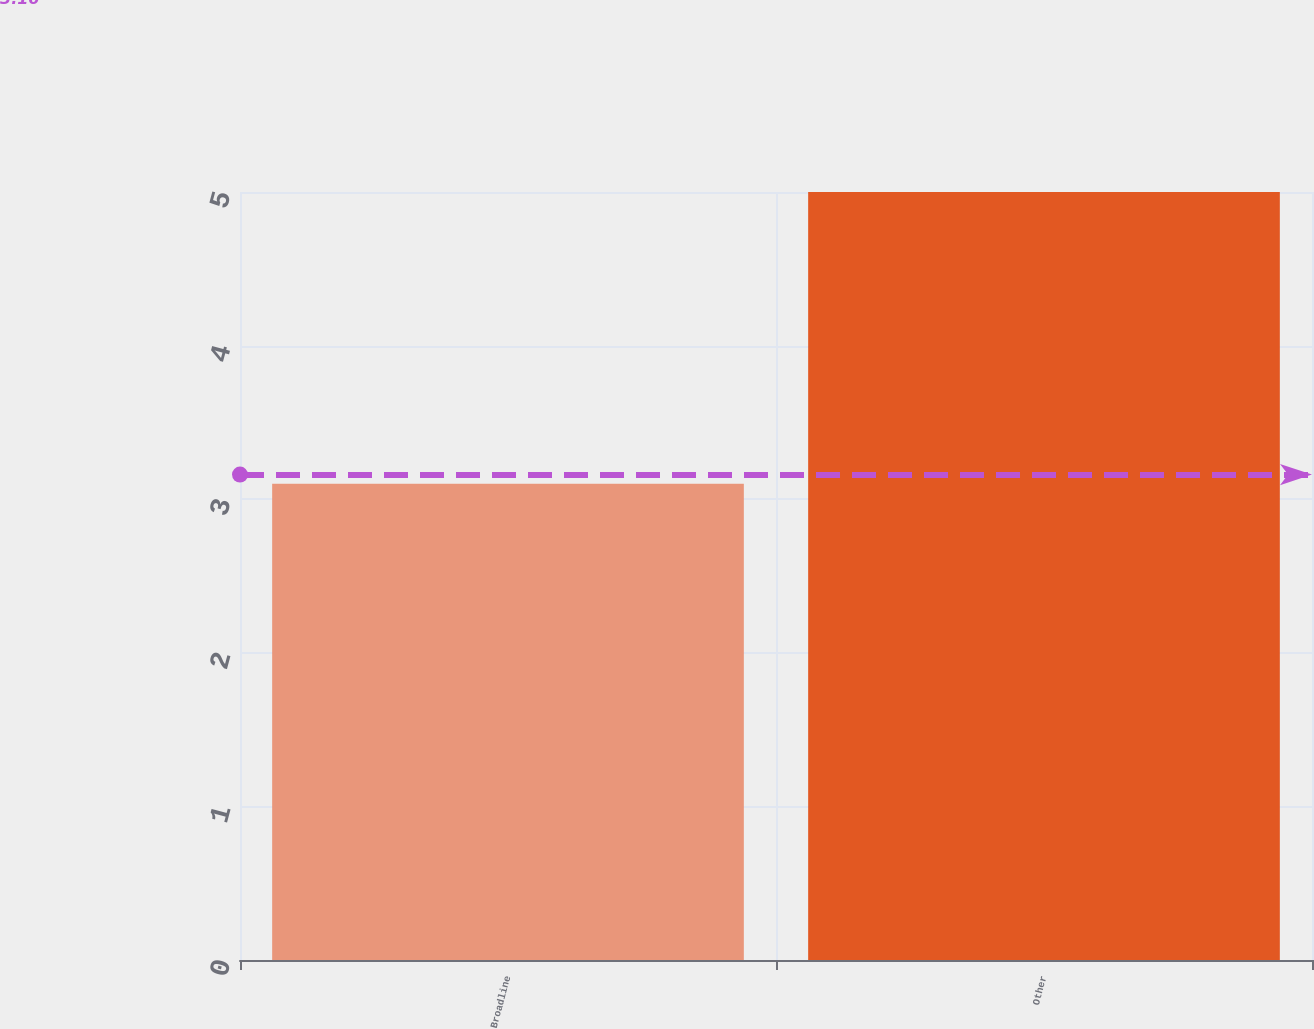Convert chart to OTSL. <chart><loc_0><loc_0><loc_500><loc_500><bar_chart><fcel>Broadline<fcel>Other<nl><fcel>3.1<fcel>5<nl></chart> 